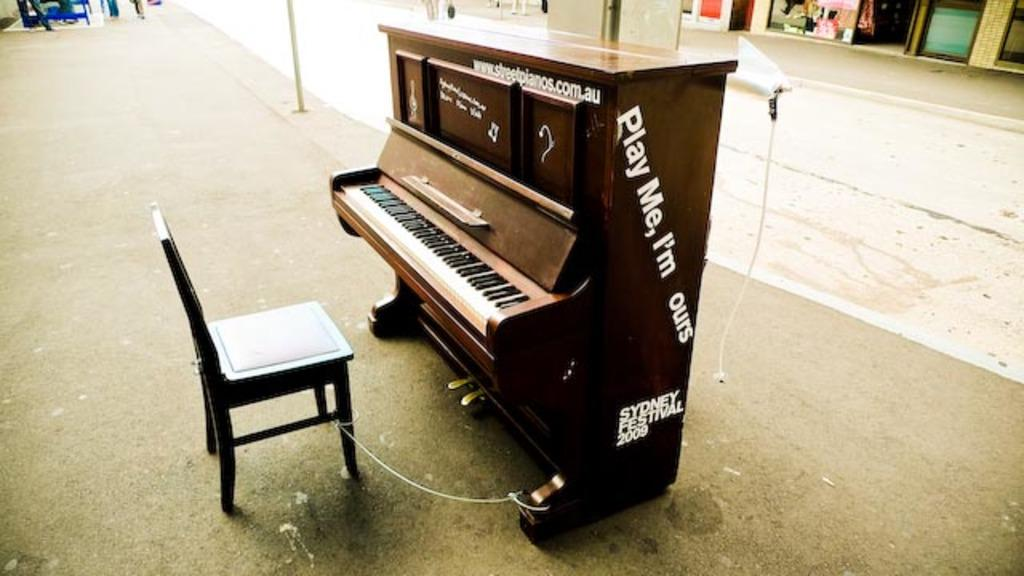What type of furniture is in the image? There is a chair in the image. What other large object can be seen in the image? There is an antique wooden piano in the image. Where are the chair and piano located in the image? The chair and piano are on the road in the image. What is visible in the background of the image? There is a building in the background of the image. What type of crook can be seen playing the piano in the image? There is no crook or any person playing the piano in the image; it is an antique wooden piano on the road. What type of marble is used to construct the chair in the image? The chair in the image is not made of marble; it is not mentioned what material the chair is made of. 